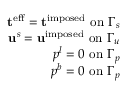Convert formula to latex. <formula><loc_0><loc_0><loc_500><loc_500>\begin{array} { r } { t ^ { e f f } = t ^ { i m p o s e d } o n \Gamma _ { s } } \\ { u ^ { s } = u ^ { i m p o s e d } o n \Gamma _ { u } } \\ { p ^ { l } = 0 o n \Gamma _ { p } } \\ { p ^ { b } = 0 o n \Gamma _ { p } } \end{array}</formula> 